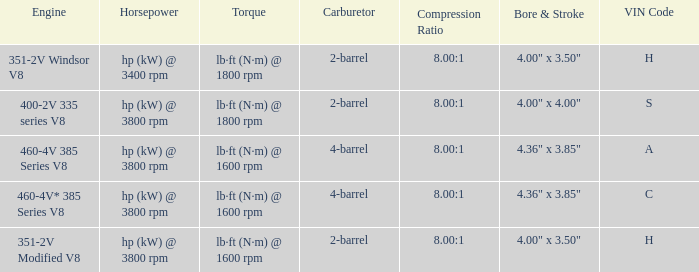Give me the full table as a dictionary. {'header': ['Engine', 'Horsepower', 'Torque', 'Carburetor', 'Compression Ratio', 'Bore & Stroke', 'VIN Code'], 'rows': [['351-2V Windsor V8', 'hp (kW) @ 3400 rpm', 'lb·ft (N·m) @ 1800 rpm', '2-barrel', '8.00:1', '4.00" x 3.50"', 'H'], ['400-2V 335 series V8', 'hp (kW) @ 3800 rpm', 'lb·ft (N·m) @ 1800 rpm', '2-barrel', '8.00:1', '4.00" x 4.00"', 'S'], ['460-4V 385 Series V8', 'hp (kW) @ 3800 rpm', 'lb·ft (N·m) @ 1600 rpm', '4-barrel', '8.00:1', '4.36" x 3.85"', 'A'], ['460-4V* 385 Series V8', 'hp (kW) @ 3800 rpm', 'lb·ft (N·m) @ 1600 rpm', '4-barrel', '8.00:1', '4.36" x 3.85"', 'C'], ['351-2V Modified V8', 'hp (kW) @ 3800 rpm', 'lb·ft (N·m) @ 1600 rpm', '2-barrel', '8.00:1', '4.00" x 3.50"', 'H']]} What are the bore & stroke specifications for an engine with 4-barrel carburetor and VIN code of A? 4.36" x 3.85". 